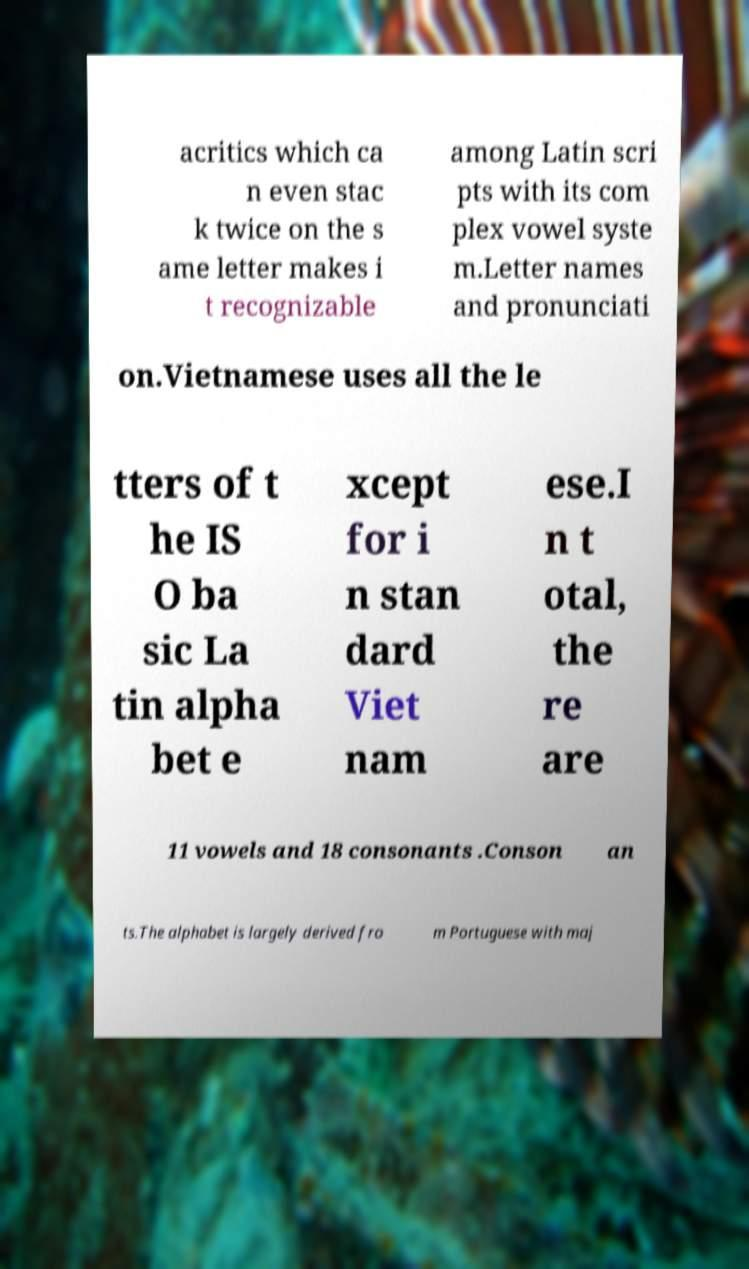For documentation purposes, I need the text within this image transcribed. Could you provide that? acritics which ca n even stac k twice on the s ame letter makes i t recognizable among Latin scri pts with its com plex vowel syste m.Letter names and pronunciati on.Vietnamese uses all the le tters of t he IS O ba sic La tin alpha bet e xcept for i n stan dard Viet nam ese.I n t otal, the re are 11 vowels and 18 consonants .Conson an ts.The alphabet is largely derived fro m Portuguese with maj 